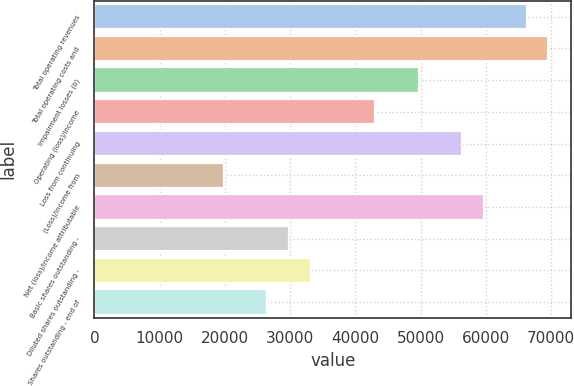Convert chart. <chart><loc_0><loc_0><loc_500><loc_500><bar_chart><fcel>Total operating revenues<fcel>Total operating costs and<fcel>Impairment losses (b)<fcel>Operating (loss)/income<fcel>Loss from continuing<fcel>(Loss)/income from<fcel>Net (loss)/income attributable<fcel>Basic shares outstanding -<fcel>Diluted shares outstanding -<fcel>Shares outstanding - end of<nl><fcel>66249.4<fcel>69561.8<fcel>49687.2<fcel>43062.3<fcel>56312.1<fcel>19875.2<fcel>59624.5<fcel>29812.5<fcel>33125<fcel>26500.1<nl></chart> 